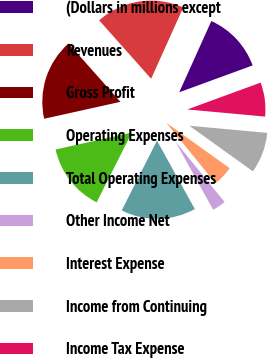Convert chart. <chart><loc_0><loc_0><loc_500><loc_500><pie_chart><fcel>(Dollars in millions except<fcel>Revenues<fcel>Gross Profit<fcel>Operating Expenses<fcel>Total Operating Expenses<fcel>Other Income Net<fcel>Interest Expense<fcel>Income from Continuing<fcel>Income Tax Expense<nl><fcel>12.68%<fcel>18.31%<fcel>16.9%<fcel>14.08%<fcel>15.49%<fcel>2.82%<fcel>4.23%<fcel>8.45%<fcel>7.04%<nl></chart> 